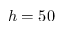<formula> <loc_0><loc_0><loc_500><loc_500>h = 5 0</formula> 